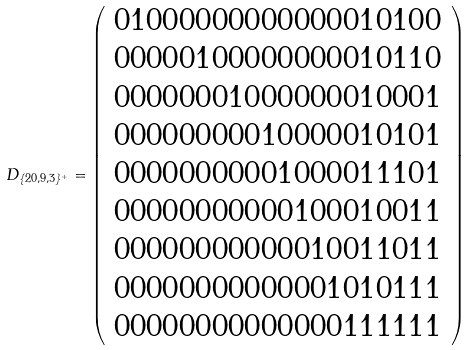<formula> <loc_0><loc_0><loc_500><loc_500>D _ { \{ 2 0 , 9 , 3 \} ^ { + } } = \left ( \begin{array} { c } 0 1 0 0 0 0 0 0 0 0 0 0 0 0 0 1 0 1 0 0 \\ 0 0 0 0 0 1 0 0 0 0 0 0 0 0 0 1 0 1 1 0 \\ 0 0 0 0 0 0 0 1 0 0 0 0 0 0 0 1 0 0 0 1 \\ 0 0 0 0 0 0 0 0 0 1 0 0 0 0 0 1 0 1 0 1 \\ 0 0 0 0 0 0 0 0 0 0 1 0 0 0 0 1 1 1 0 1 \\ 0 0 0 0 0 0 0 0 0 0 0 1 0 0 0 1 0 0 1 1 \\ 0 0 0 0 0 0 0 0 0 0 0 0 1 0 0 1 1 0 1 1 \\ 0 0 0 0 0 0 0 0 0 0 0 0 0 1 0 1 0 1 1 1 \\ 0 0 0 0 0 0 0 0 0 0 0 0 0 0 1 1 1 1 1 1 \end{array} \right )</formula> 